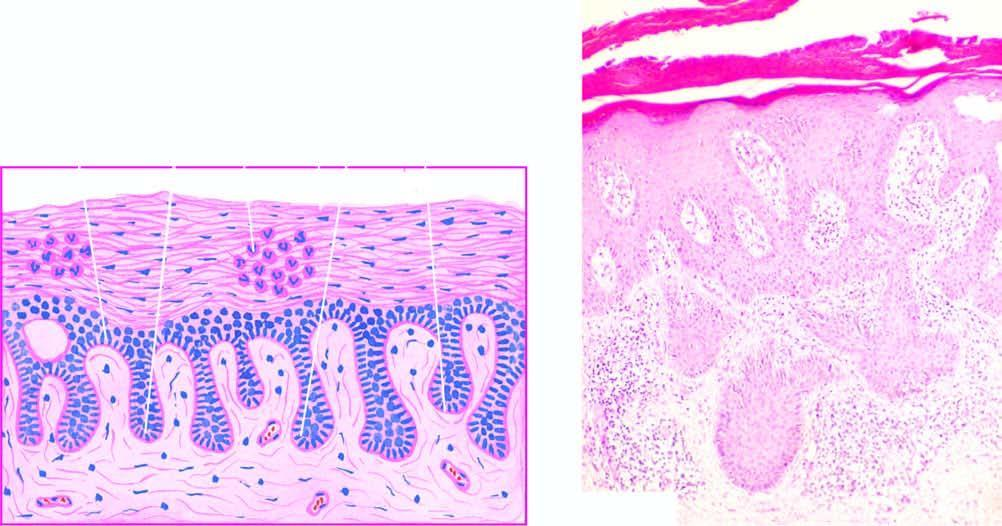what is there with thickening of their lower portion?
Answer the question using a single word or phrase. Regular elongation of the rete ridges 